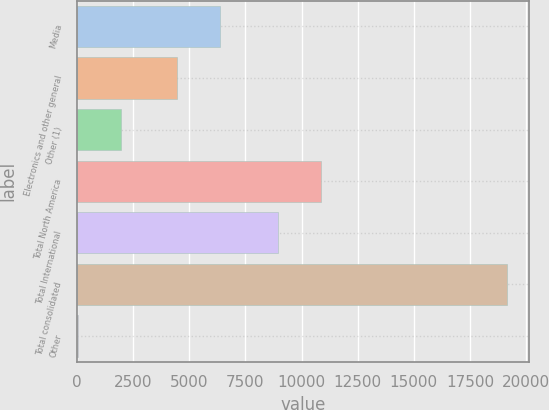Convert chart. <chart><loc_0><loc_0><loc_500><loc_500><bar_chart><fcel>Media<fcel>Electronics and other general<fcel>Other (1)<fcel>Total North America<fcel>Total International<fcel>Total consolidated<fcel>Other<nl><fcel>6342.8<fcel>4430<fcel>1950.8<fcel>10850.8<fcel>8938<fcel>19166<fcel>38<nl></chart> 